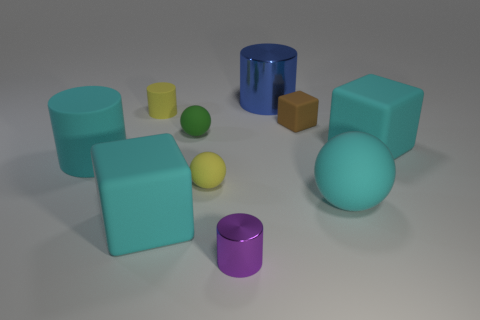There is a ball that is the same color as the small rubber cylinder; what size is it? The ball, sharing the same vivid green color as the small rubber cylinder, is also small in size. It's similar in dimension to the cylinder, dwarfed by the larger geometric shapes surrounding it. 